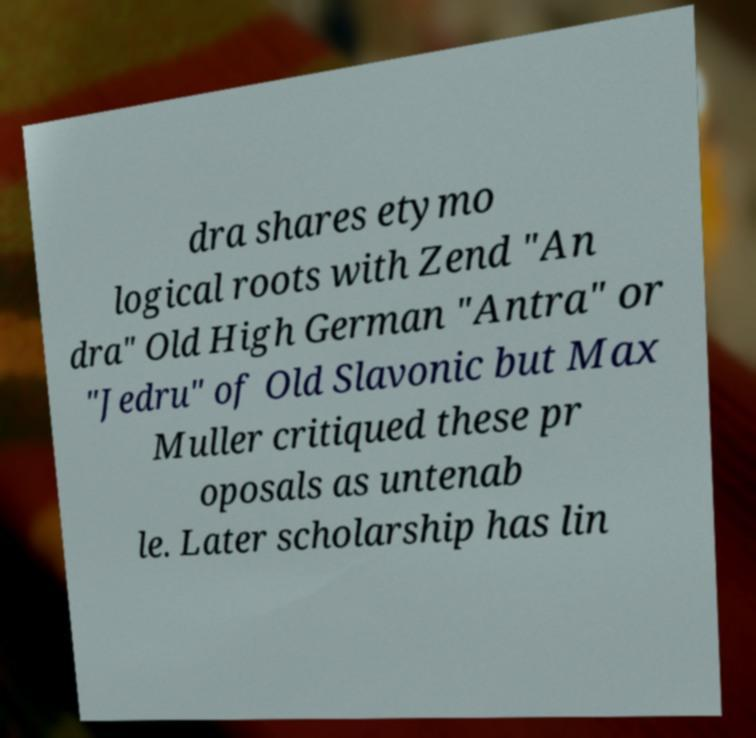Can you accurately transcribe the text from the provided image for me? dra shares etymo logical roots with Zend "An dra" Old High German "Antra" or "Jedru" of Old Slavonic but Max Muller critiqued these pr oposals as untenab le. Later scholarship has lin 